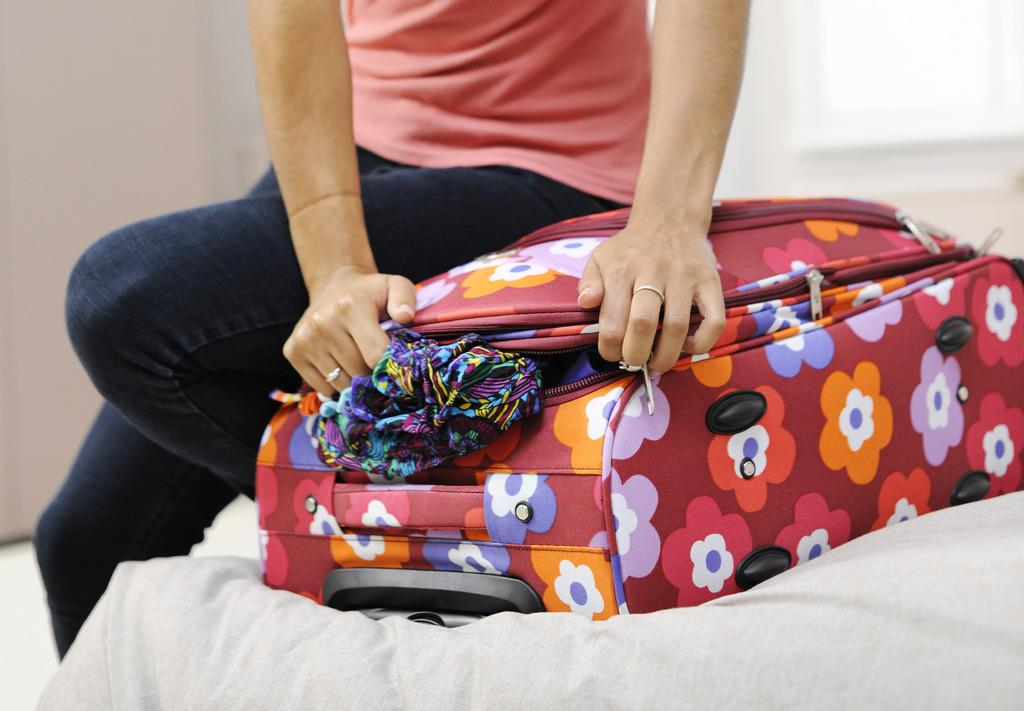Who is in the image? There is a person in the image. What is the person doing? The person is standing and closing a suitcase. What is inside the suitcase? There are clothes inside the suitcase. What type of food is the person holding in the image? There is no food present in the image; the person is closing a suitcase with clothes inside. Can you see any flowers in the image? There are no flowers visible in the image. 